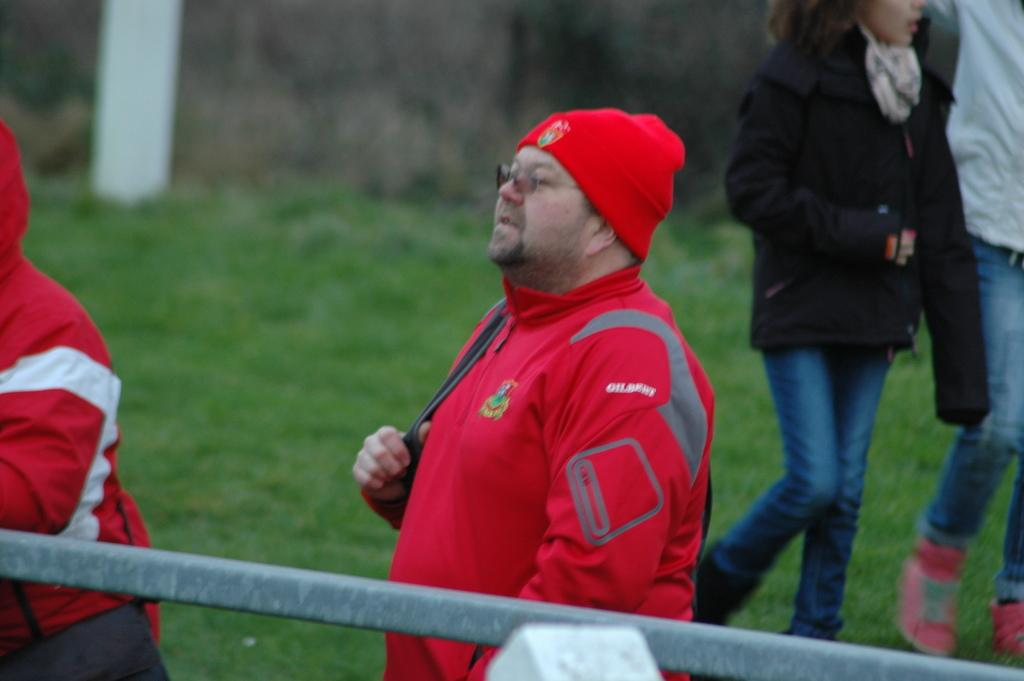Who or what is present in the image? There are people in the image. What type of surface is at the bottom of the image? There is grass at the bottom of the image. What object can be seen in the image besides the people? There is a pole in the image. What adjustment is being made to the finger in the image? There is no finger or adjustment present in the image. 